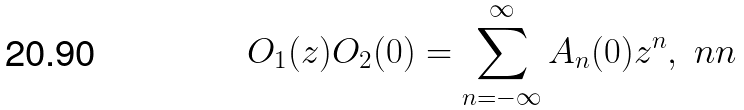Convert formula to latex. <formula><loc_0><loc_0><loc_500><loc_500>O _ { 1 } ( z ) O _ { 2 } ( 0 ) = \sum _ { n = - \infty } ^ { \infty } A _ { n } ( 0 ) z ^ { n } , \ n n</formula> 